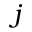<formula> <loc_0><loc_0><loc_500><loc_500>j</formula> 